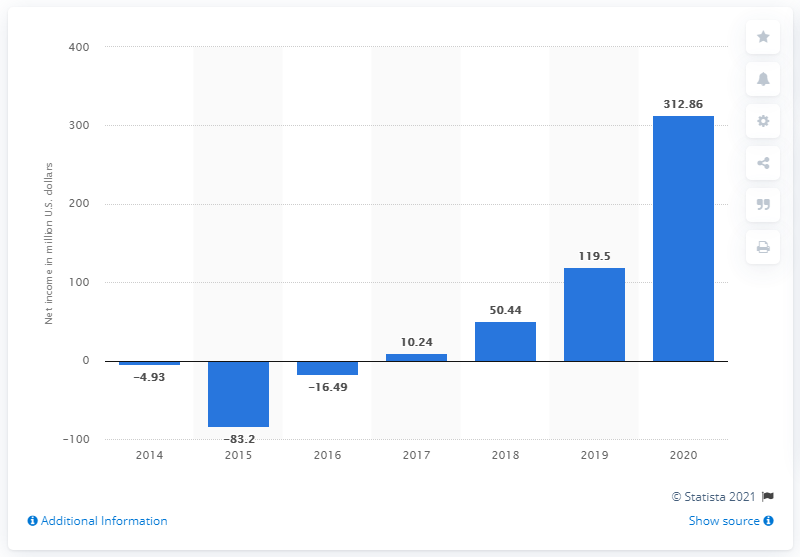Identify some key points in this picture. In 2020, the global net income of Crocs was 312.86 million dollars. 